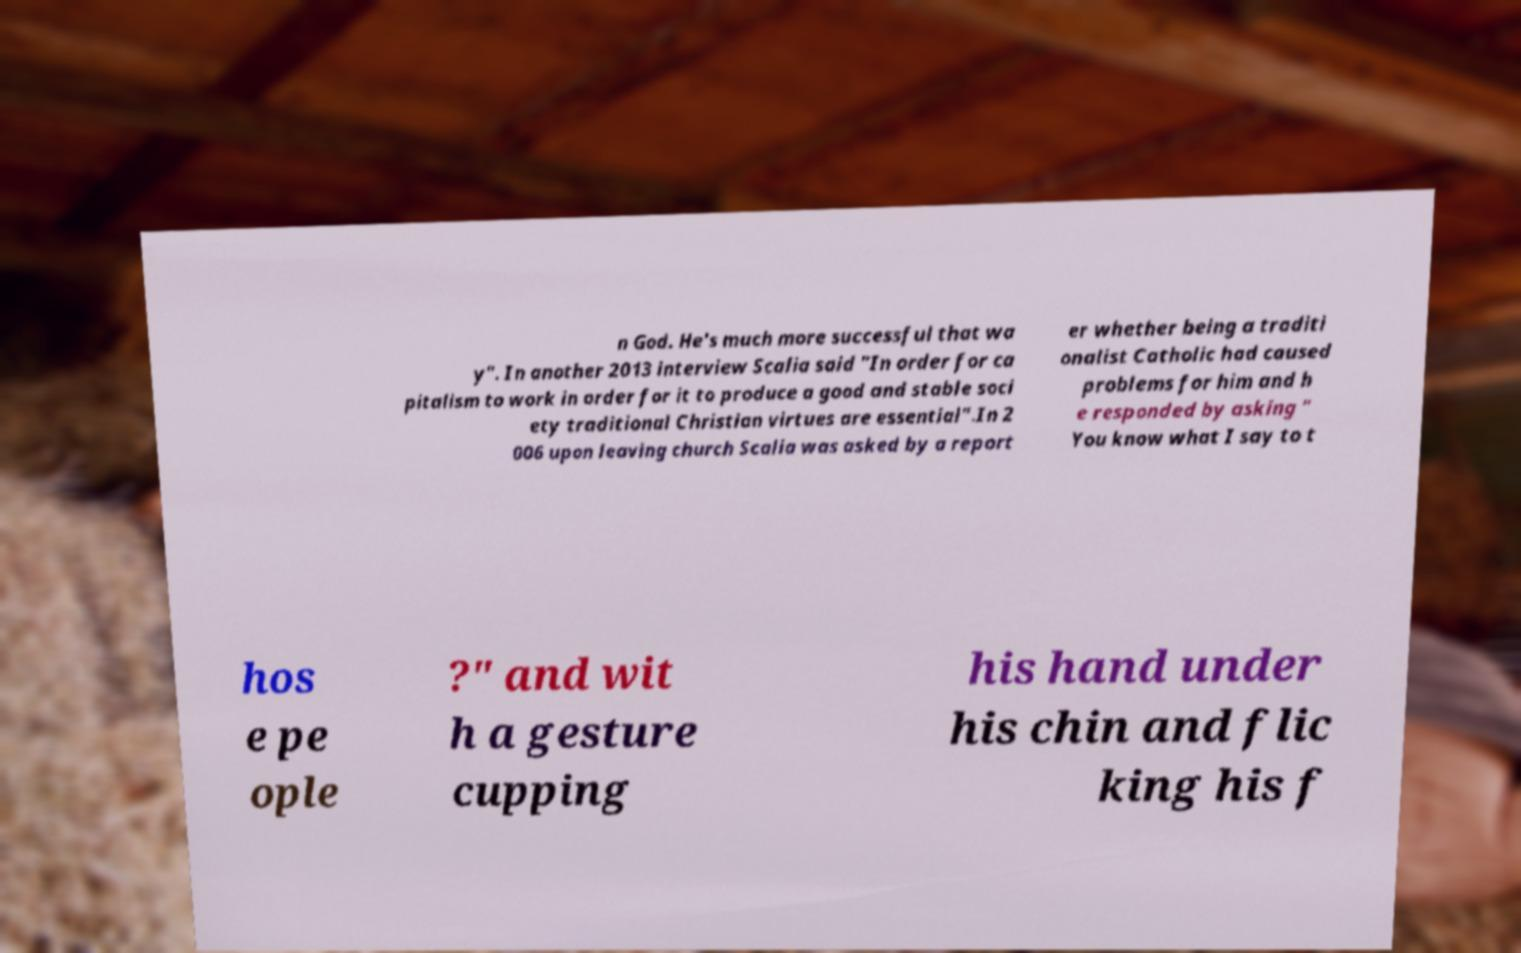Please read and relay the text visible in this image. What does it say? n God. He's much more successful that wa y". In another 2013 interview Scalia said "In order for ca pitalism to work in order for it to produce a good and stable soci ety traditional Christian virtues are essential".In 2 006 upon leaving church Scalia was asked by a report er whether being a traditi onalist Catholic had caused problems for him and h e responded by asking " You know what I say to t hos e pe ople ?" and wit h a gesture cupping his hand under his chin and flic king his f 